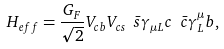<formula> <loc_0><loc_0><loc_500><loc_500>H _ { e f f } = { \frac { G _ { F } } { \sqrt { 2 } } } V _ { c b } V _ { c s } \ \bar { s } \gamma _ { \mu L } c \ \bar { c } \gamma _ { L } ^ { \mu } b ,</formula> 